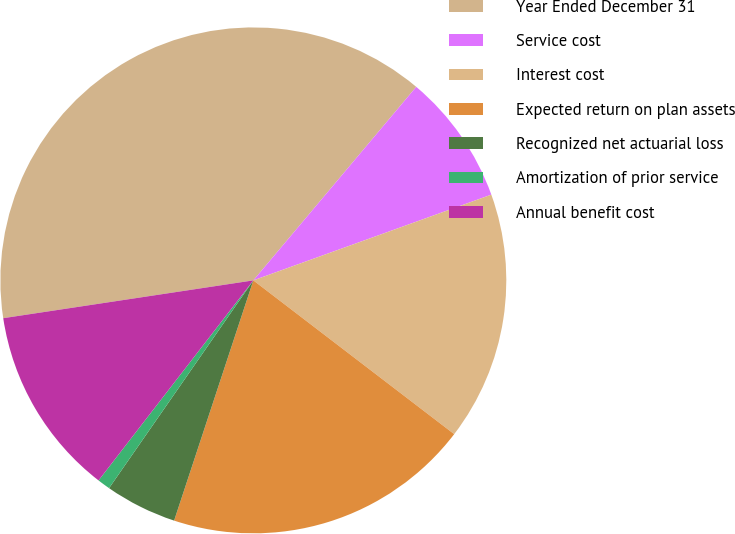Convert chart to OTSL. <chart><loc_0><loc_0><loc_500><loc_500><pie_chart><fcel>Year Ended December 31<fcel>Service cost<fcel>Interest cost<fcel>Expected return on plan assets<fcel>Recognized net actuarial loss<fcel>Amortization of prior service<fcel>Annual benefit cost<nl><fcel>38.52%<fcel>8.36%<fcel>15.9%<fcel>19.67%<fcel>4.59%<fcel>0.82%<fcel>12.13%<nl></chart> 